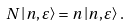<formula> <loc_0><loc_0><loc_500><loc_500>N \left | n , \varepsilon \right \rangle = n \left | n , \varepsilon \right \rangle .</formula> 